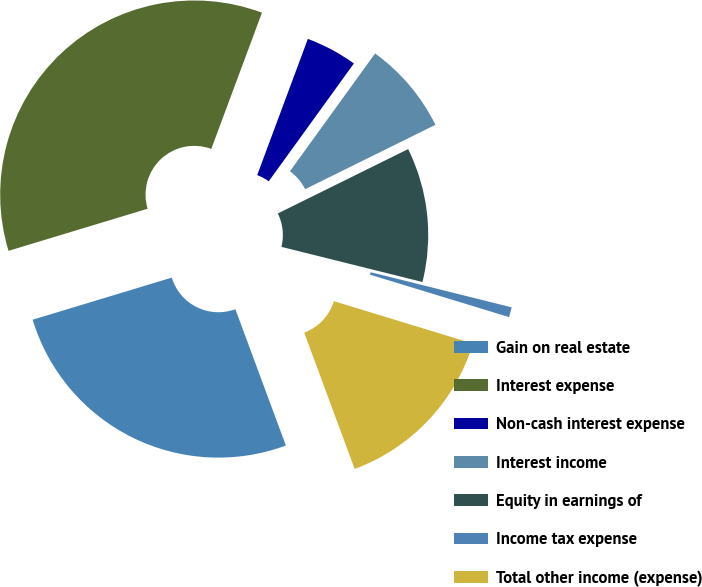Convert chart. <chart><loc_0><loc_0><loc_500><loc_500><pie_chart><fcel>Gain on real estate<fcel>Interest expense<fcel>Non-cash interest expense<fcel>Interest income<fcel>Equity in earnings of<fcel>Income tax expense<fcel>Total other income (expense)<nl><fcel>25.97%<fcel>35.35%<fcel>4.29%<fcel>7.74%<fcel>11.19%<fcel>0.83%<fcel>14.64%<nl></chart> 